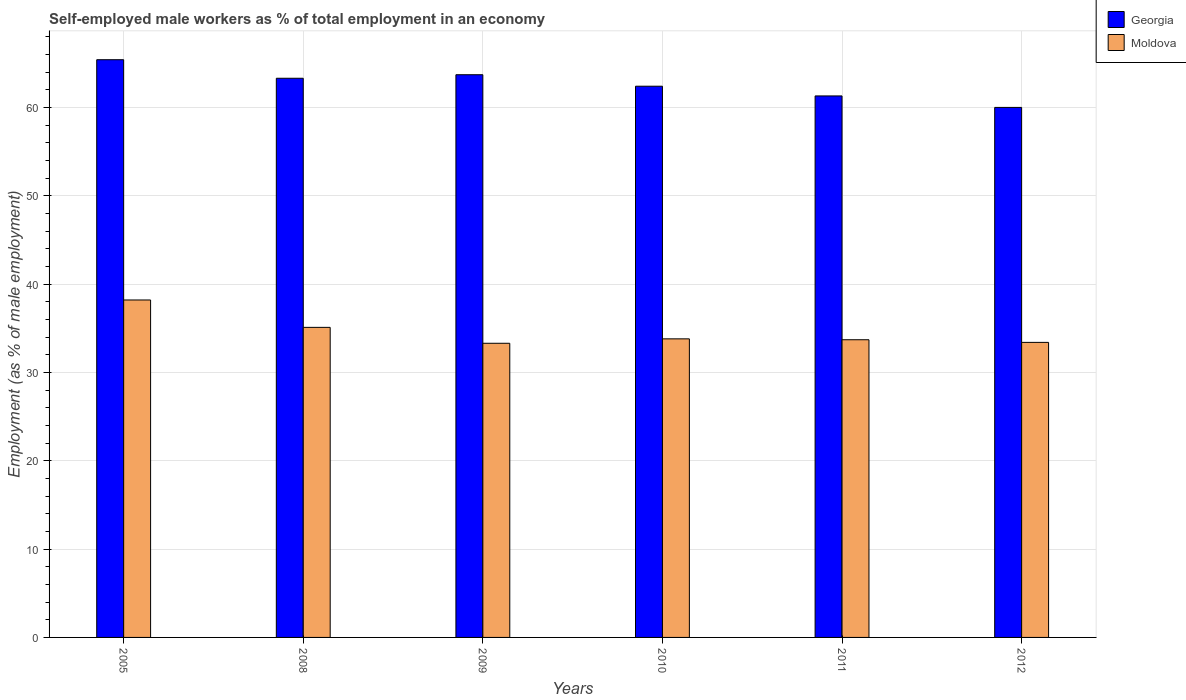How many different coloured bars are there?
Your response must be concise. 2. What is the label of the 2nd group of bars from the left?
Your answer should be compact. 2008. In how many cases, is the number of bars for a given year not equal to the number of legend labels?
Ensure brevity in your answer.  0. What is the percentage of self-employed male workers in Moldova in 2005?
Provide a short and direct response. 38.2. Across all years, what is the maximum percentage of self-employed male workers in Moldova?
Keep it short and to the point. 38.2. Across all years, what is the minimum percentage of self-employed male workers in Moldova?
Provide a succinct answer. 33.3. In which year was the percentage of self-employed male workers in Moldova minimum?
Provide a succinct answer. 2009. What is the total percentage of self-employed male workers in Moldova in the graph?
Your response must be concise. 207.5. What is the difference between the percentage of self-employed male workers in Moldova in 2008 and that in 2011?
Keep it short and to the point. 1.4. What is the average percentage of self-employed male workers in Moldova per year?
Make the answer very short. 34.58. In the year 2012, what is the difference between the percentage of self-employed male workers in Moldova and percentage of self-employed male workers in Georgia?
Your answer should be compact. -26.6. What is the ratio of the percentage of self-employed male workers in Moldova in 2005 to that in 2010?
Keep it short and to the point. 1.13. Is the percentage of self-employed male workers in Moldova in 2009 less than that in 2011?
Offer a terse response. Yes. Is the difference between the percentage of self-employed male workers in Moldova in 2009 and 2011 greater than the difference between the percentage of self-employed male workers in Georgia in 2009 and 2011?
Offer a terse response. No. What is the difference between the highest and the second highest percentage of self-employed male workers in Georgia?
Your response must be concise. 1.7. What is the difference between the highest and the lowest percentage of self-employed male workers in Georgia?
Ensure brevity in your answer.  5.4. In how many years, is the percentage of self-employed male workers in Georgia greater than the average percentage of self-employed male workers in Georgia taken over all years?
Your response must be concise. 3. What does the 1st bar from the left in 2011 represents?
Give a very brief answer. Georgia. What does the 2nd bar from the right in 2009 represents?
Give a very brief answer. Georgia. Are all the bars in the graph horizontal?
Keep it short and to the point. No. Are the values on the major ticks of Y-axis written in scientific E-notation?
Offer a terse response. No. Where does the legend appear in the graph?
Offer a terse response. Top right. How many legend labels are there?
Your answer should be compact. 2. How are the legend labels stacked?
Ensure brevity in your answer.  Vertical. What is the title of the graph?
Your response must be concise. Self-employed male workers as % of total employment in an economy. Does "Channel Islands" appear as one of the legend labels in the graph?
Ensure brevity in your answer.  No. What is the label or title of the X-axis?
Your answer should be very brief. Years. What is the label or title of the Y-axis?
Offer a very short reply. Employment (as % of male employment). What is the Employment (as % of male employment) in Georgia in 2005?
Offer a terse response. 65.4. What is the Employment (as % of male employment) of Moldova in 2005?
Offer a very short reply. 38.2. What is the Employment (as % of male employment) in Georgia in 2008?
Your answer should be very brief. 63.3. What is the Employment (as % of male employment) in Moldova in 2008?
Your answer should be compact. 35.1. What is the Employment (as % of male employment) in Georgia in 2009?
Provide a succinct answer. 63.7. What is the Employment (as % of male employment) in Moldova in 2009?
Your answer should be very brief. 33.3. What is the Employment (as % of male employment) in Georgia in 2010?
Offer a terse response. 62.4. What is the Employment (as % of male employment) of Moldova in 2010?
Provide a short and direct response. 33.8. What is the Employment (as % of male employment) of Georgia in 2011?
Your answer should be compact. 61.3. What is the Employment (as % of male employment) of Moldova in 2011?
Keep it short and to the point. 33.7. What is the Employment (as % of male employment) of Moldova in 2012?
Your response must be concise. 33.4. Across all years, what is the maximum Employment (as % of male employment) of Georgia?
Give a very brief answer. 65.4. Across all years, what is the maximum Employment (as % of male employment) of Moldova?
Ensure brevity in your answer.  38.2. Across all years, what is the minimum Employment (as % of male employment) in Moldova?
Ensure brevity in your answer.  33.3. What is the total Employment (as % of male employment) of Georgia in the graph?
Your answer should be very brief. 376.1. What is the total Employment (as % of male employment) of Moldova in the graph?
Your response must be concise. 207.5. What is the difference between the Employment (as % of male employment) in Georgia in 2005 and that in 2009?
Your answer should be very brief. 1.7. What is the difference between the Employment (as % of male employment) of Moldova in 2005 and that in 2009?
Make the answer very short. 4.9. What is the difference between the Employment (as % of male employment) in Georgia in 2005 and that in 2011?
Give a very brief answer. 4.1. What is the difference between the Employment (as % of male employment) in Moldova in 2005 and that in 2011?
Offer a terse response. 4.5. What is the difference between the Employment (as % of male employment) of Moldova in 2008 and that in 2009?
Keep it short and to the point. 1.8. What is the difference between the Employment (as % of male employment) of Moldova in 2008 and that in 2010?
Give a very brief answer. 1.3. What is the difference between the Employment (as % of male employment) of Moldova in 2008 and that in 2011?
Offer a terse response. 1.4. What is the difference between the Employment (as % of male employment) of Georgia in 2008 and that in 2012?
Keep it short and to the point. 3.3. What is the difference between the Employment (as % of male employment) of Moldova in 2008 and that in 2012?
Keep it short and to the point. 1.7. What is the difference between the Employment (as % of male employment) in Moldova in 2009 and that in 2010?
Provide a succinct answer. -0.5. What is the difference between the Employment (as % of male employment) in Moldova in 2010 and that in 2012?
Your answer should be compact. 0.4. What is the difference between the Employment (as % of male employment) in Georgia in 2011 and that in 2012?
Your response must be concise. 1.3. What is the difference between the Employment (as % of male employment) of Georgia in 2005 and the Employment (as % of male employment) of Moldova in 2008?
Ensure brevity in your answer.  30.3. What is the difference between the Employment (as % of male employment) of Georgia in 2005 and the Employment (as % of male employment) of Moldova in 2009?
Your answer should be compact. 32.1. What is the difference between the Employment (as % of male employment) of Georgia in 2005 and the Employment (as % of male employment) of Moldova in 2010?
Your answer should be very brief. 31.6. What is the difference between the Employment (as % of male employment) in Georgia in 2005 and the Employment (as % of male employment) in Moldova in 2011?
Offer a very short reply. 31.7. What is the difference between the Employment (as % of male employment) of Georgia in 2005 and the Employment (as % of male employment) of Moldova in 2012?
Ensure brevity in your answer.  32. What is the difference between the Employment (as % of male employment) of Georgia in 2008 and the Employment (as % of male employment) of Moldova in 2010?
Your answer should be very brief. 29.5. What is the difference between the Employment (as % of male employment) of Georgia in 2008 and the Employment (as % of male employment) of Moldova in 2011?
Your response must be concise. 29.6. What is the difference between the Employment (as % of male employment) in Georgia in 2008 and the Employment (as % of male employment) in Moldova in 2012?
Your answer should be compact. 29.9. What is the difference between the Employment (as % of male employment) of Georgia in 2009 and the Employment (as % of male employment) of Moldova in 2010?
Give a very brief answer. 29.9. What is the difference between the Employment (as % of male employment) of Georgia in 2009 and the Employment (as % of male employment) of Moldova in 2011?
Your response must be concise. 30. What is the difference between the Employment (as % of male employment) in Georgia in 2009 and the Employment (as % of male employment) in Moldova in 2012?
Ensure brevity in your answer.  30.3. What is the difference between the Employment (as % of male employment) of Georgia in 2010 and the Employment (as % of male employment) of Moldova in 2011?
Your response must be concise. 28.7. What is the difference between the Employment (as % of male employment) of Georgia in 2010 and the Employment (as % of male employment) of Moldova in 2012?
Your answer should be compact. 29. What is the difference between the Employment (as % of male employment) of Georgia in 2011 and the Employment (as % of male employment) of Moldova in 2012?
Give a very brief answer. 27.9. What is the average Employment (as % of male employment) in Georgia per year?
Your response must be concise. 62.68. What is the average Employment (as % of male employment) in Moldova per year?
Offer a very short reply. 34.58. In the year 2005, what is the difference between the Employment (as % of male employment) of Georgia and Employment (as % of male employment) of Moldova?
Give a very brief answer. 27.2. In the year 2008, what is the difference between the Employment (as % of male employment) of Georgia and Employment (as % of male employment) of Moldova?
Provide a succinct answer. 28.2. In the year 2009, what is the difference between the Employment (as % of male employment) in Georgia and Employment (as % of male employment) in Moldova?
Keep it short and to the point. 30.4. In the year 2010, what is the difference between the Employment (as % of male employment) in Georgia and Employment (as % of male employment) in Moldova?
Offer a very short reply. 28.6. In the year 2011, what is the difference between the Employment (as % of male employment) of Georgia and Employment (as % of male employment) of Moldova?
Ensure brevity in your answer.  27.6. In the year 2012, what is the difference between the Employment (as % of male employment) in Georgia and Employment (as % of male employment) in Moldova?
Provide a short and direct response. 26.6. What is the ratio of the Employment (as % of male employment) in Georgia in 2005 to that in 2008?
Provide a short and direct response. 1.03. What is the ratio of the Employment (as % of male employment) in Moldova in 2005 to that in 2008?
Give a very brief answer. 1.09. What is the ratio of the Employment (as % of male employment) in Georgia in 2005 to that in 2009?
Ensure brevity in your answer.  1.03. What is the ratio of the Employment (as % of male employment) of Moldova in 2005 to that in 2009?
Give a very brief answer. 1.15. What is the ratio of the Employment (as % of male employment) of Georgia in 2005 to that in 2010?
Offer a very short reply. 1.05. What is the ratio of the Employment (as % of male employment) in Moldova in 2005 to that in 2010?
Give a very brief answer. 1.13. What is the ratio of the Employment (as % of male employment) of Georgia in 2005 to that in 2011?
Keep it short and to the point. 1.07. What is the ratio of the Employment (as % of male employment) of Moldova in 2005 to that in 2011?
Your answer should be very brief. 1.13. What is the ratio of the Employment (as % of male employment) of Georgia in 2005 to that in 2012?
Make the answer very short. 1.09. What is the ratio of the Employment (as % of male employment) of Moldova in 2005 to that in 2012?
Offer a very short reply. 1.14. What is the ratio of the Employment (as % of male employment) of Moldova in 2008 to that in 2009?
Keep it short and to the point. 1.05. What is the ratio of the Employment (as % of male employment) in Georgia in 2008 to that in 2010?
Offer a terse response. 1.01. What is the ratio of the Employment (as % of male employment) of Georgia in 2008 to that in 2011?
Give a very brief answer. 1.03. What is the ratio of the Employment (as % of male employment) of Moldova in 2008 to that in 2011?
Make the answer very short. 1.04. What is the ratio of the Employment (as % of male employment) of Georgia in 2008 to that in 2012?
Your answer should be compact. 1.05. What is the ratio of the Employment (as % of male employment) of Moldova in 2008 to that in 2012?
Offer a terse response. 1.05. What is the ratio of the Employment (as % of male employment) of Georgia in 2009 to that in 2010?
Provide a succinct answer. 1.02. What is the ratio of the Employment (as % of male employment) of Moldova in 2009 to that in 2010?
Keep it short and to the point. 0.99. What is the ratio of the Employment (as % of male employment) of Georgia in 2009 to that in 2011?
Give a very brief answer. 1.04. What is the ratio of the Employment (as % of male employment) of Moldova in 2009 to that in 2011?
Give a very brief answer. 0.99. What is the ratio of the Employment (as % of male employment) of Georgia in 2009 to that in 2012?
Your answer should be very brief. 1.06. What is the ratio of the Employment (as % of male employment) in Georgia in 2010 to that in 2011?
Ensure brevity in your answer.  1.02. What is the ratio of the Employment (as % of male employment) of Moldova in 2010 to that in 2011?
Your response must be concise. 1. What is the ratio of the Employment (as % of male employment) in Moldova in 2010 to that in 2012?
Your answer should be very brief. 1.01. What is the ratio of the Employment (as % of male employment) in Georgia in 2011 to that in 2012?
Ensure brevity in your answer.  1.02. What is the difference between the highest and the lowest Employment (as % of male employment) of Georgia?
Provide a short and direct response. 5.4. What is the difference between the highest and the lowest Employment (as % of male employment) of Moldova?
Make the answer very short. 4.9. 